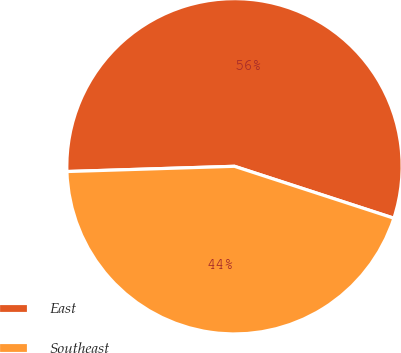<chart> <loc_0><loc_0><loc_500><loc_500><pie_chart><fcel>East<fcel>Southeast<nl><fcel>55.51%<fcel>44.49%<nl></chart> 